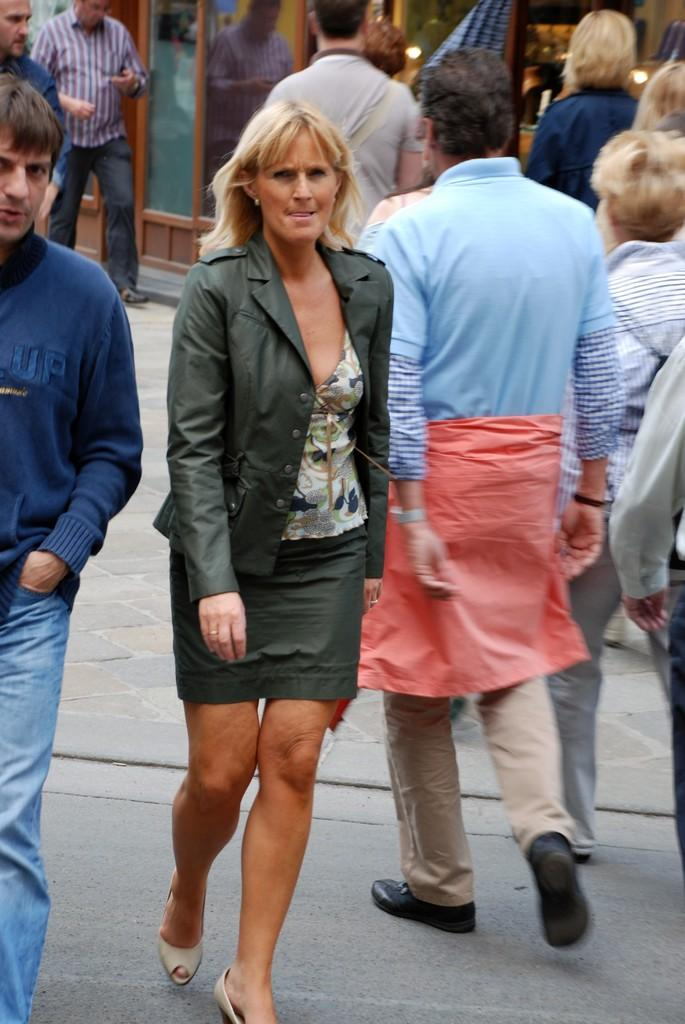What are the people in the image doing? The people in the image are walking. What object can be seen in the background of the image? There is a glass in the background of the image. Can you describe any additional details about the glass? The reflection of a person is visible on the glass. Can you tell me how many fish are swimming in the glass in the image? There are no fish present in the image; it features a glass with a reflection of a person. Is there a chicken visible in the image? There is no chicken present in the image. 